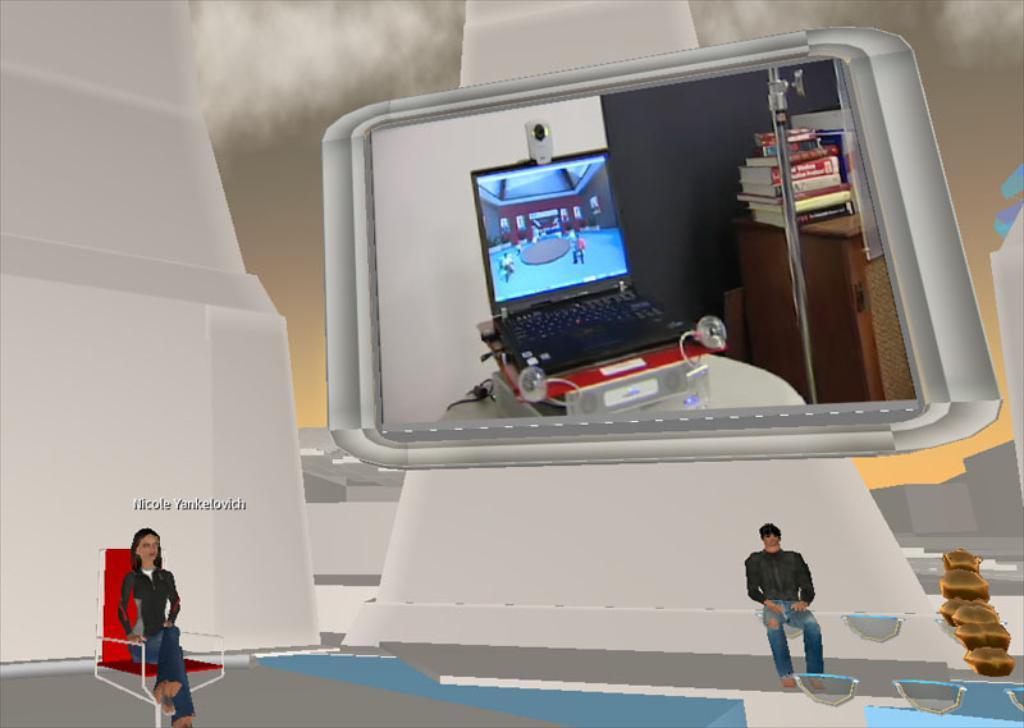Can you describe this image briefly? It is the animation image in which there is a mirror. In the mirror we can see that there is a laptop. On the laptop there is a webcam, Beside the laptop there are books on the table. At the bottom there is a girl sitting on the chair. On the right side there is a boy sitting on the wall. 